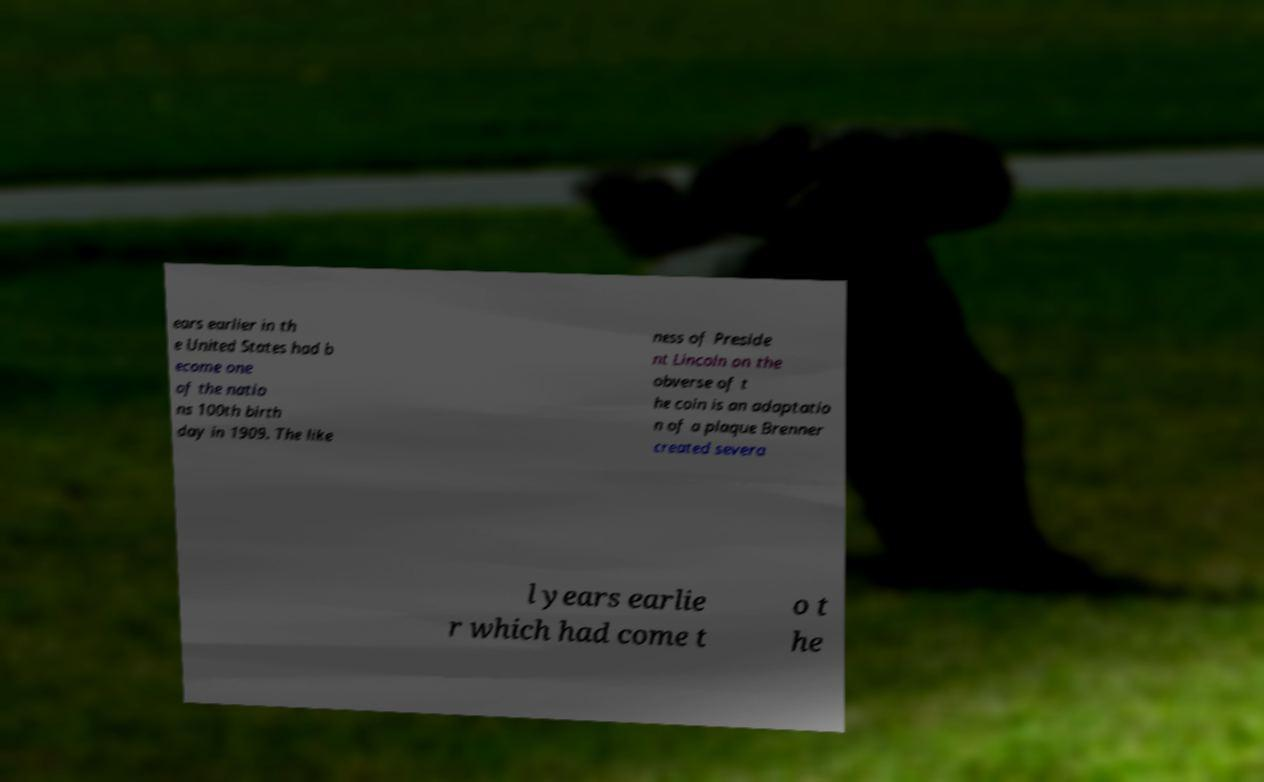Please identify and transcribe the text found in this image. ears earlier in th e United States had b ecome one of the natio ns 100th birth day in 1909. The like ness of Preside nt Lincoln on the obverse of t he coin is an adaptatio n of a plaque Brenner created severa l years earlie r which had come t o t he 